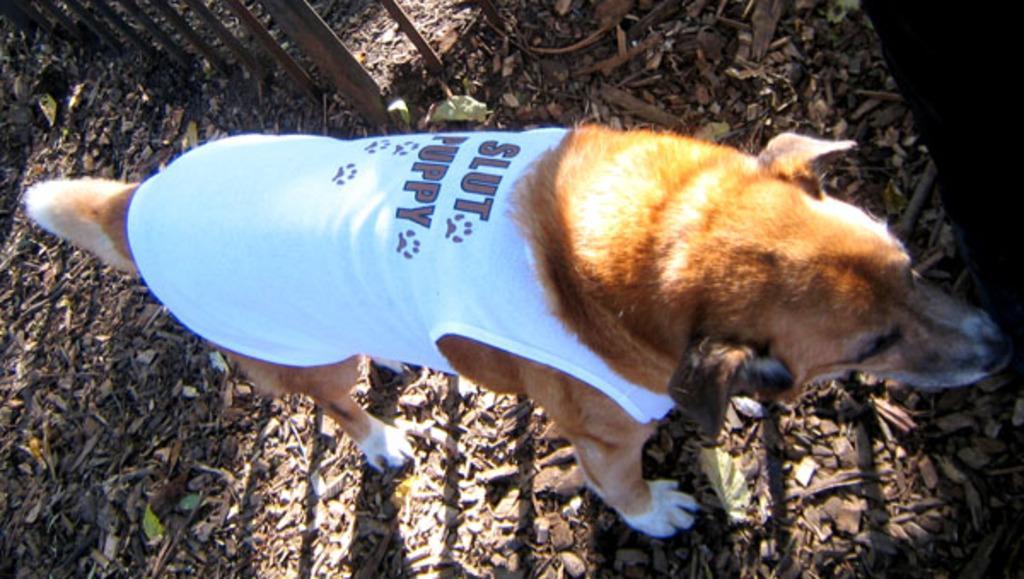In one or two sentences, can you explain what this image depicts? This image is taken outdoors. At the bottom of the image there is a ground. There are a few dry leaves on the ground and there are many pebbles on the ground. In the background there is a fence. In the middle of the image there is a dog. 